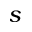Convert formula to latex. <formula><loc_0><loc_0><loc_500><loc_500>s</formula> 